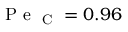Convert formula to latex. <formula><loc_0><loc_0><loc_500><loc_500>P e _ { C } = 0 . 9 6</formula> 